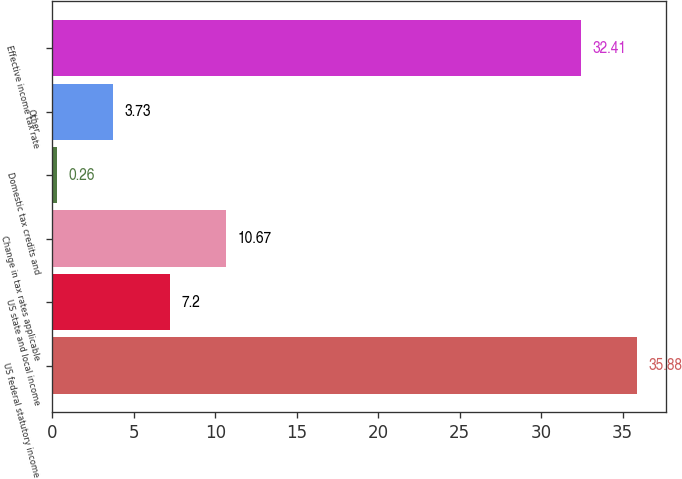Convert chart. <chart><loc_0><loc_0><loc_500><loc_500><bar_chart><fcel>US federal statutory income<fcel>US state and local income<fcel>Change in tax rates applicable<fcel>Domestic tax credits and<fcel>Other<fcel>Effective income tax rate<nl><fcel>35.88<fcel>7.2<fcel>10.67<fcel>0.26<fcel>3.73<fcel>32.41<nl></chart> 